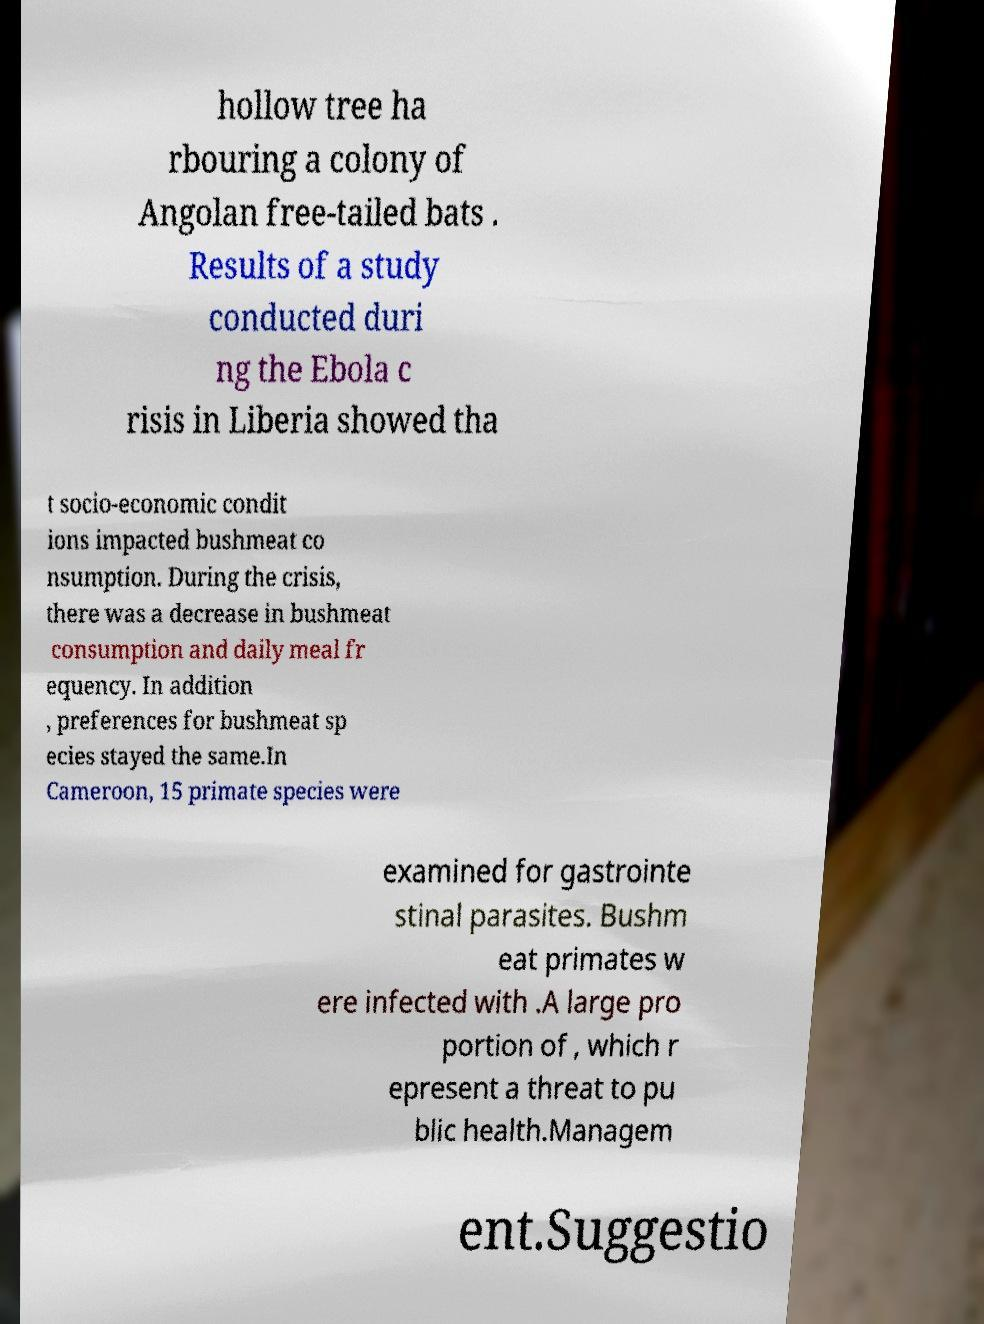There's text embedded in this image that I need extracted. Can you transcribe it verbatim? hollow tree ha rbouring a colony of Angolan free-tailed bats . Results of a study conducted duri ng the Ebola c risis in Liberia showed tha t socio-economic condit ions impacted bushmeat co nsumption. During the crisis, there was a decrease in bushmeat consumption and daily meal fr equency. In addition , preferences for bushmeat sp ecies stayed the same.In Cameroon, 15 primate species were examined for gastrointe stinal parasites. Bushm eat primates w ere infected with .A large pro portion of , which r epresent a threat to pu blic health.Managem ent.Suggestio 